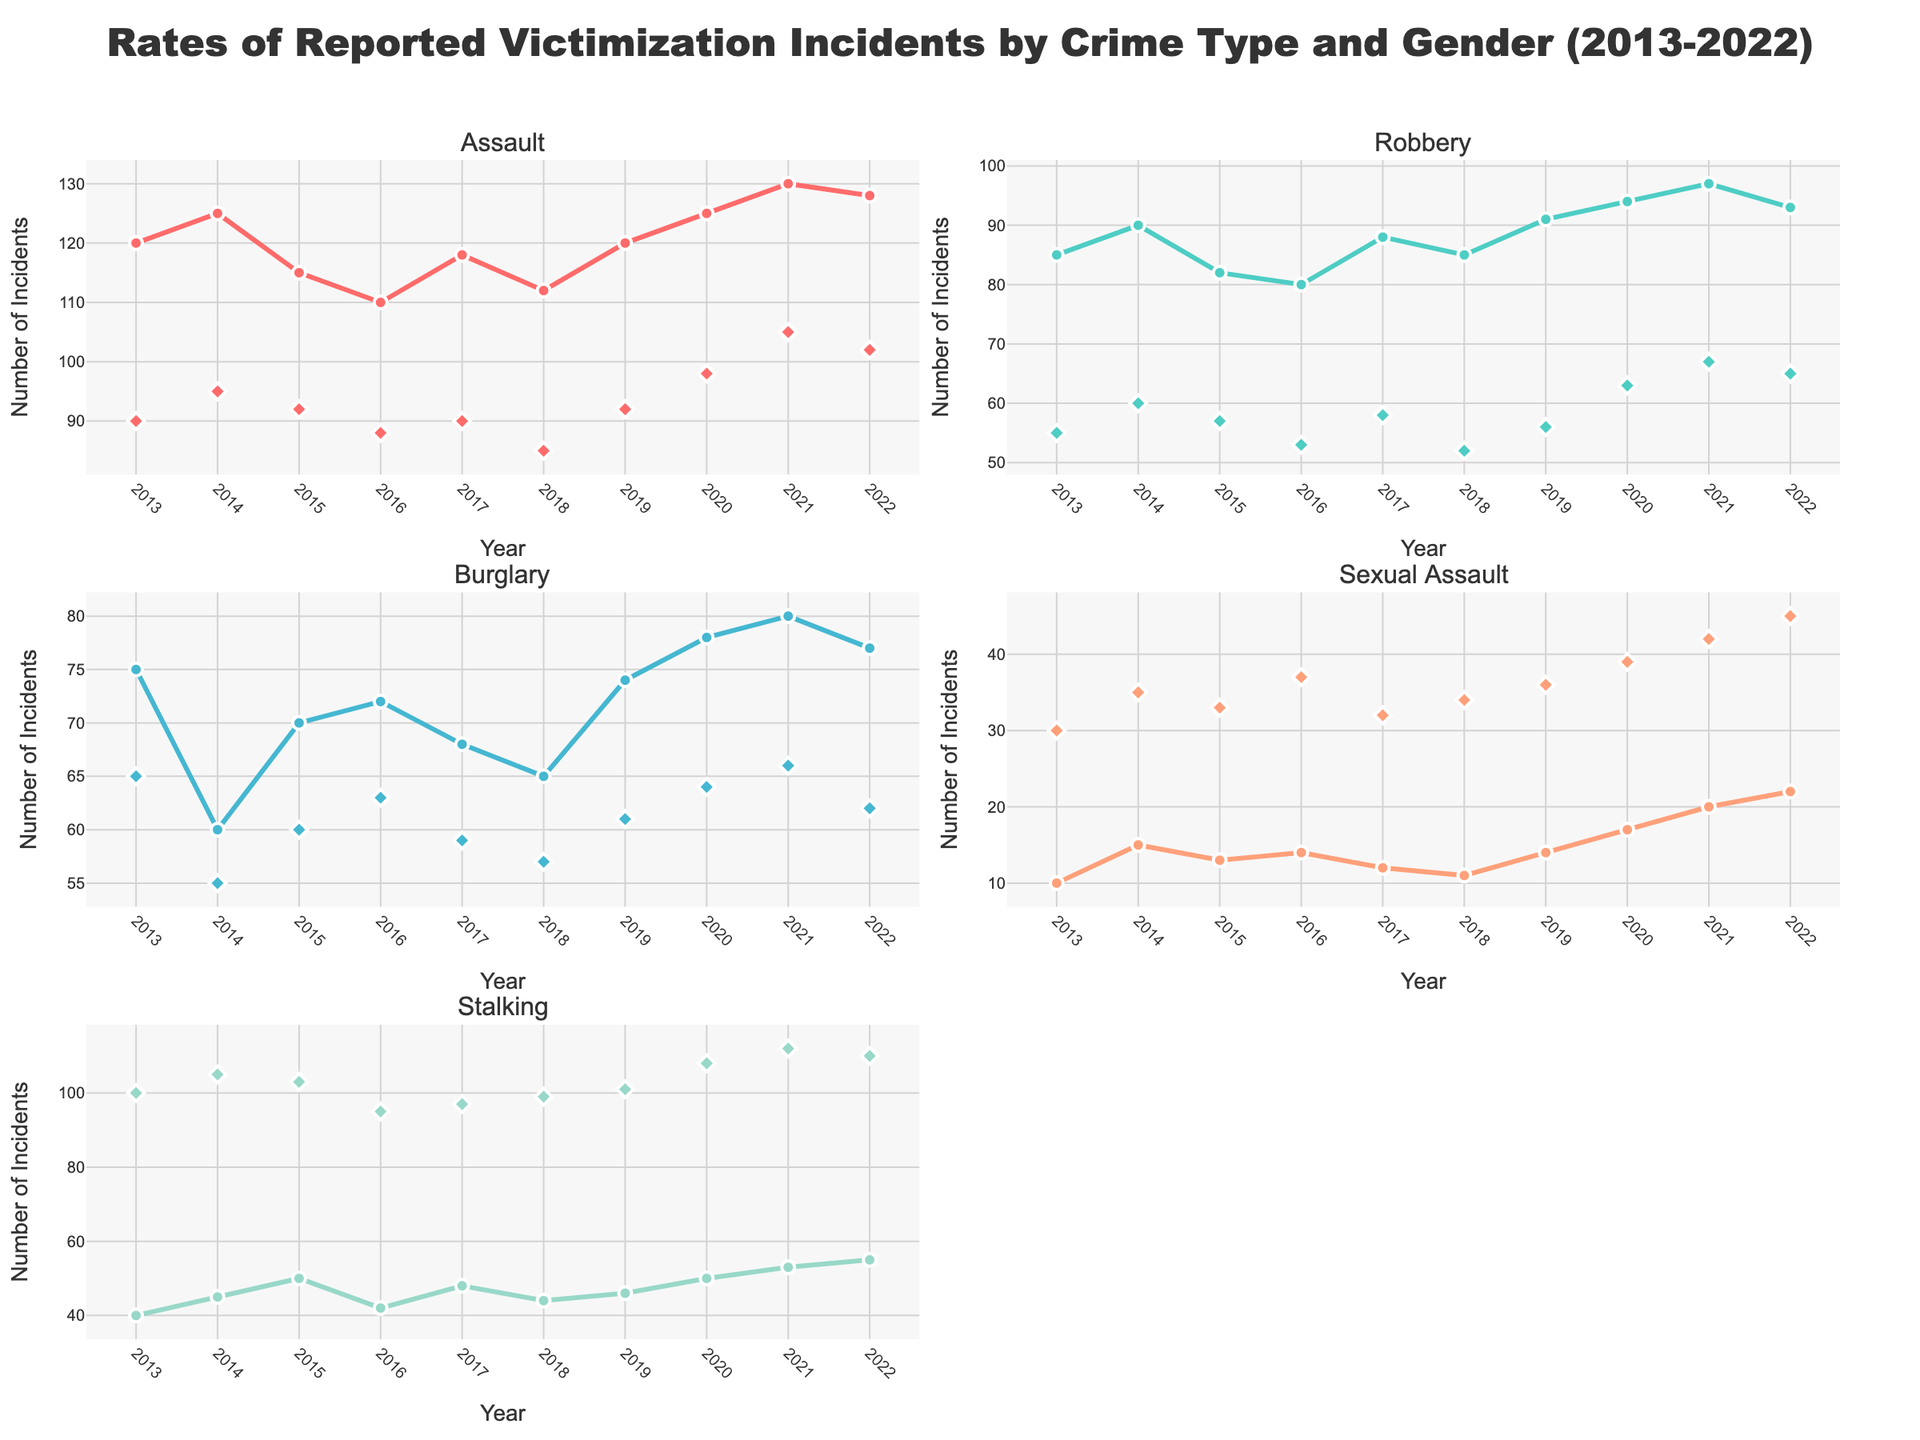What is the title of the figure? The title of the figure is located at the top and provides an overview of what the figure represents.
Answer: Rates of Reported Victimization Incidents by Crime Type and Gender (2013-2022) Which gender had a higher rate of reported stalking incidents in 2020? Locate the subplot for Stalking and observe the data points for 2020 for both genders. The Female data point is higher than the Male data point in 2020.
Answer: Female What trend can be observed for the rates of reported assaults for males from 2013 to 2022? Examine the line with markers representing the male population in the Assault subplot. The trend shows a general increase from 2013 to 2022.
Answer: Increasing What year did females report the highest number of sexual assault incidents? Look at the subplot for Sexual Assault and find the peak data point in the Female series.
Answer: 2022 How has the rate of reported burglary incidents for females changed from 2013 to 2022? Locate the line with markers representing females in the Burglary subplot. Compare the 2013 and 2022 data points to analyze the change.
Answer: Decreased Between 2017 and 2018, which crime type saw a decrease in reported incidents for males? Check all the male data series for each crime type between 2017 and 2018 to identify any decreases. Burglary and Sexual Assault show a decrease for males between 2017 and 2018.
Answer: Burglary and Sexual Assault What is the average rate of reported robbery incidents for males over the decade? To calculate the average, sum the robbery incident values for males from 2013 to 2022 and then divide by the number of years. (85+90+82+80+88+85+91+94+97+93)/10 = 88.5
Answer: 88.5 Which crime type shows the highest total reported incidents for females over the decade? For each crime type subplot, sum the values for females from 2013 to 2022 and compare the totals to find the highest. Sexual Assault: (30+35+33+37+32+34+36+39+42+45) = 363, Stalking: (100+105+103+95+97+99+101+108+112+110) = 1030
Answer: Stalking In which year did the gender gap in reported assault incidents appear the narrowest? To identify the smallest gender gap in Assault incidents, subtract the female rates from the male rates for each year and find the year with the smallest difference.
Answer: 2016 